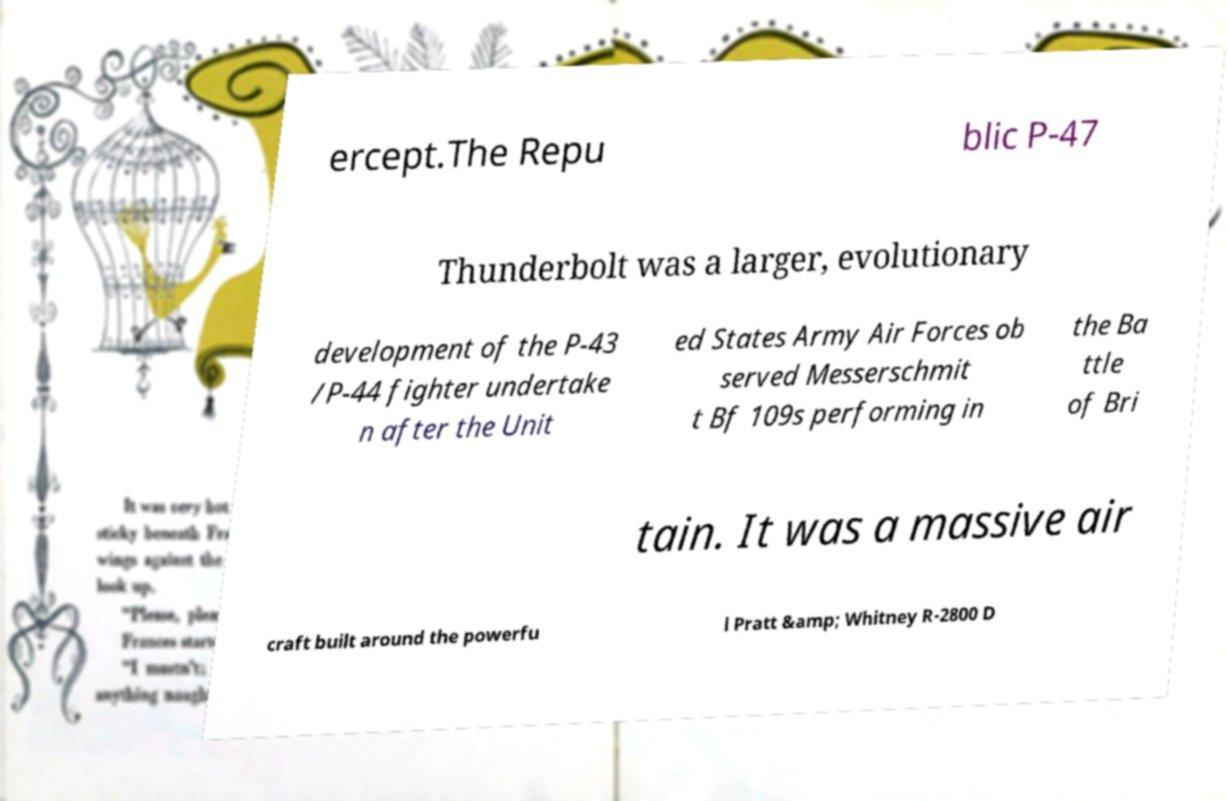There's text embedded in this image that I need extracted. Can you transcribe it verbatim? ercept.The Repu blic P-47 Thunderbolt was a larger, evolutionary development of the P-43 /P-44 fighter undertake n after the Unit ed States Army Air Forces ob served Messerschmit t Bf 109s performing in the Ba ttle of Bri tain. It was a massive air craft built around the powerfu l Pratt &amp; Whitney R-2800 D 